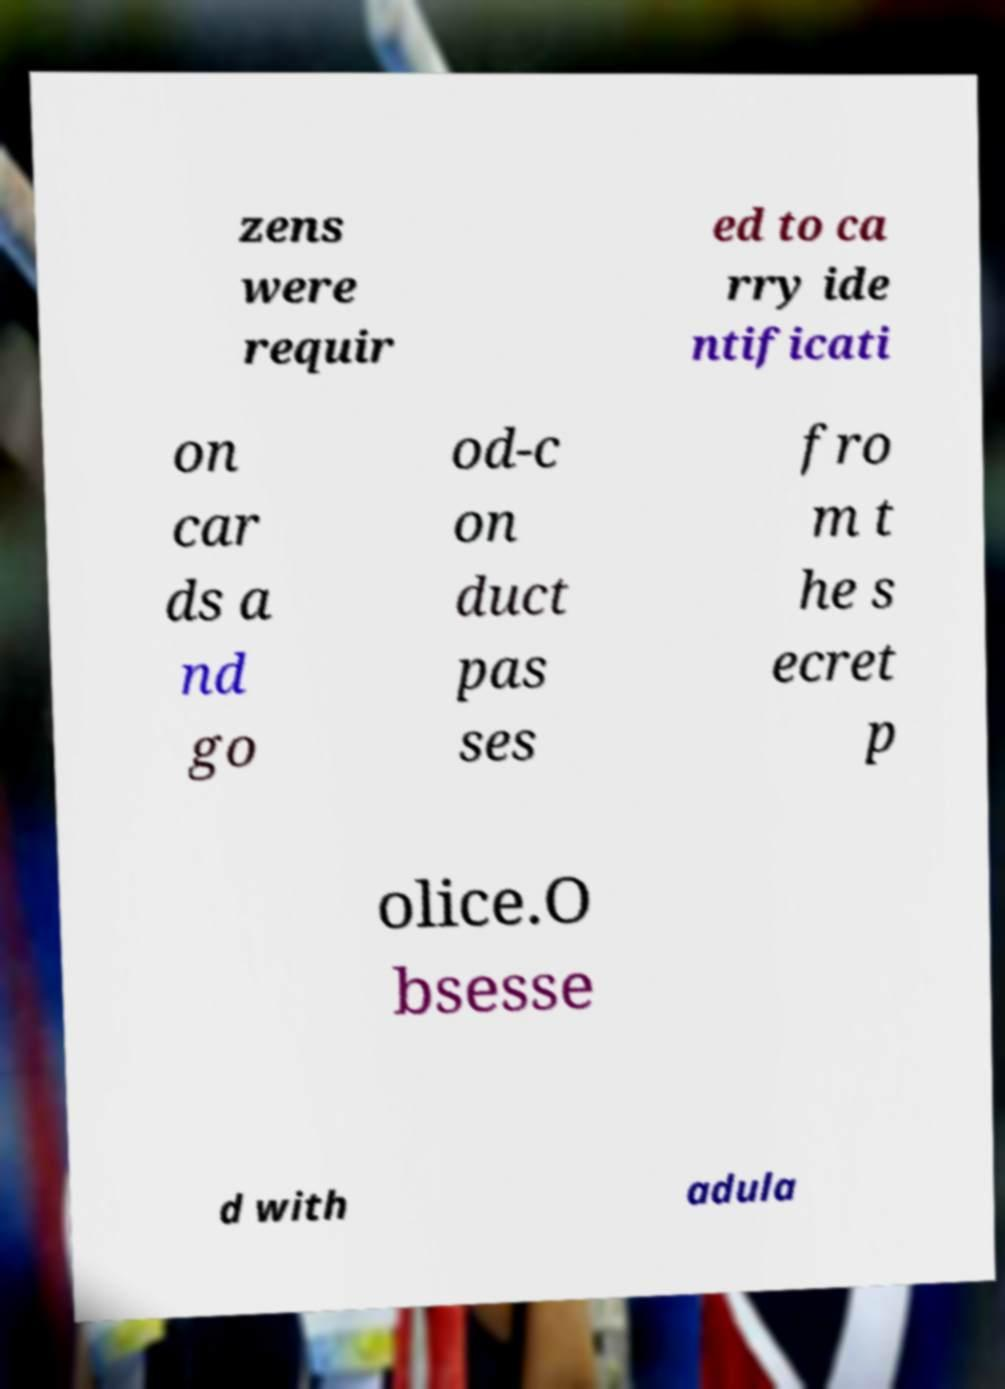For documentation purposes, I need the text within this image transcribed. Could you provide that? zens were requir ed to ca rry ide ntificati on car ds a nd go od-c on duct pas ses fro m t he s ecret p olice.O bsesse d with adula 